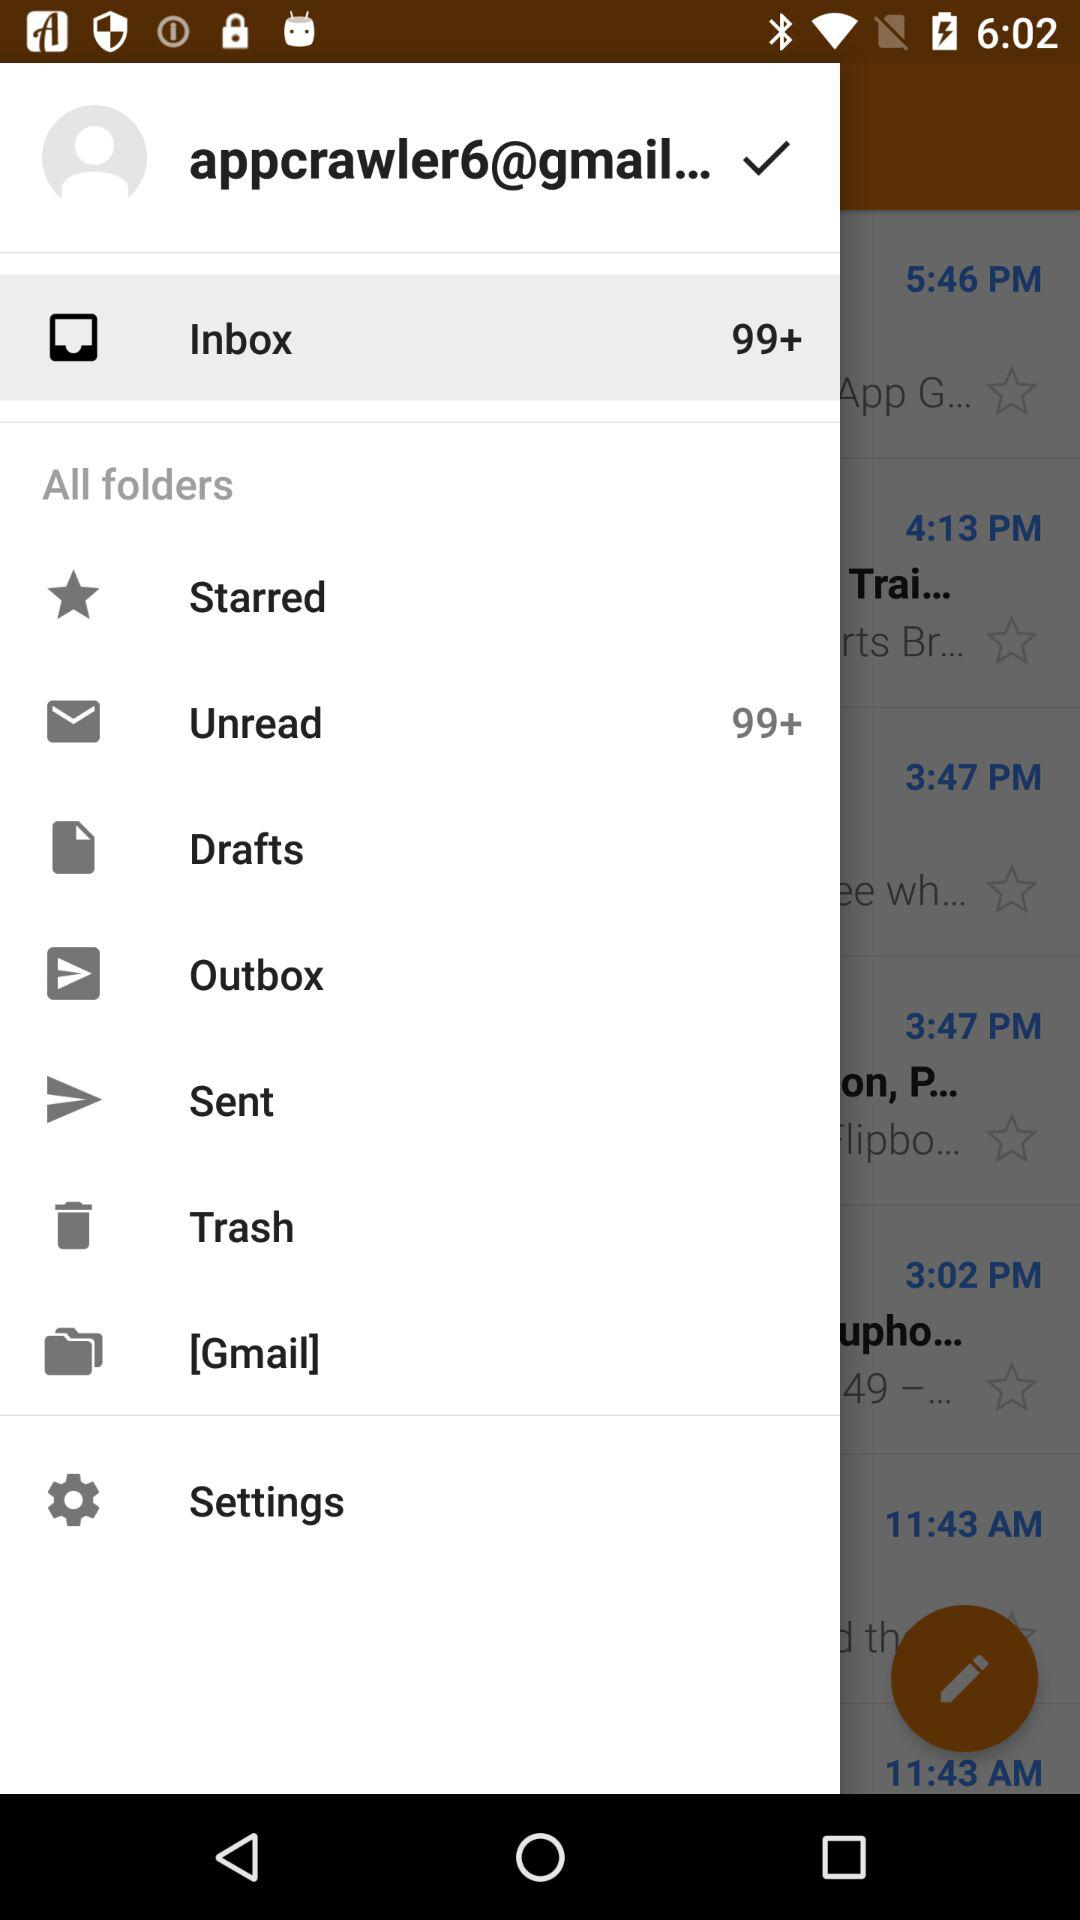When was the last email sent?
When the provided information is insufficient, respond with <no answer>. <no answer> 